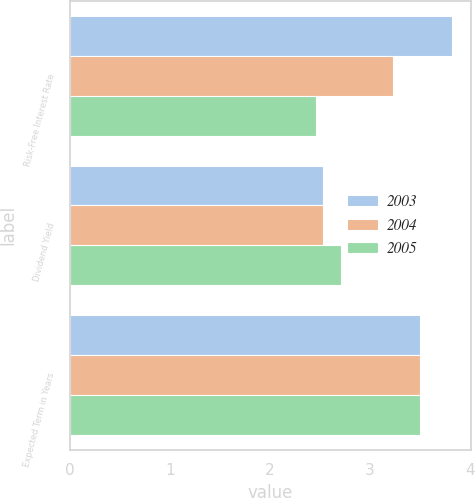Convert chart. <chart><loc_0><loc_0><loc_500><loc_500><stacked_bar_chart><ecel><fcel>Risk-Free Interest Rate<fcel>Dividend Yield<fcel>Expected Term in Years<nl><fcel>2003<fcel>3.82<fcel>2.53<fcel>3.5<nl><fcel>2004<fcel>3.23<fcel>2.53<fcel>3.5<nl><fcel>2005<fcel>2.46<fcel>2.71<fcel>3.5<nl></chart> 